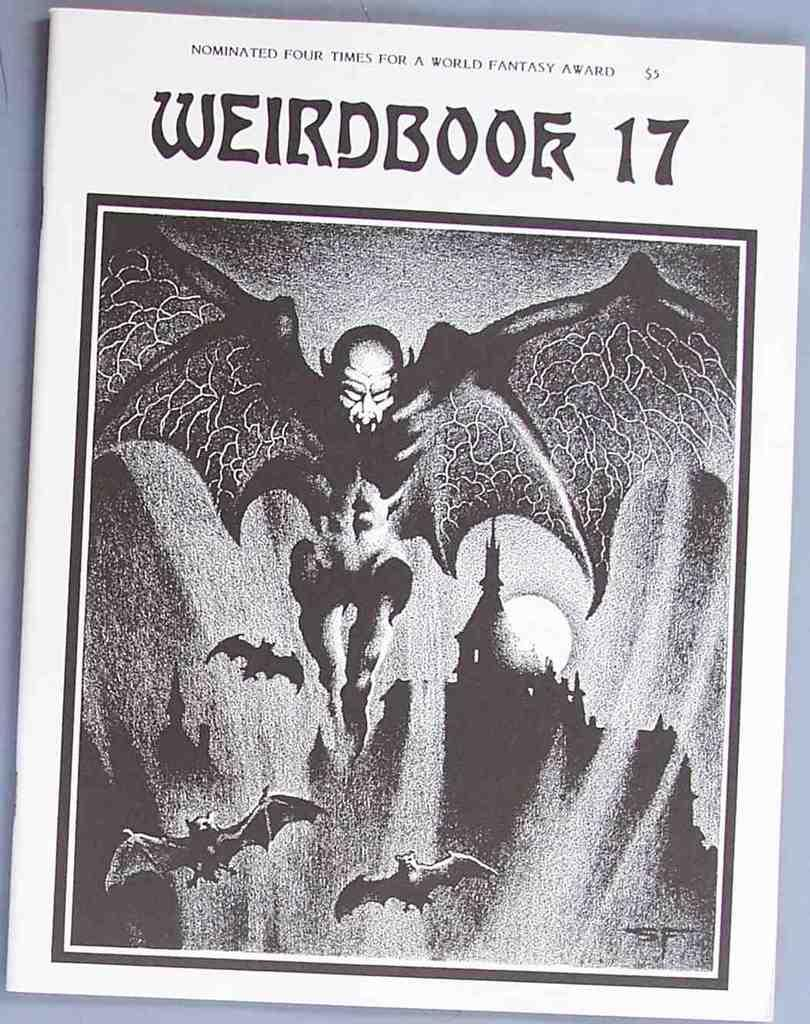What object is present in the image that is typically used for reading? There is a book in the image. What can be found on the book? There is text and a sketch on the book. What type of watch is depicted in the sketch on the book? There is no watch depicted in the sketch on the book; the sketch is not described in the facts provided. 